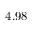<formula> <loc_0><loc_0><loc_500><loc_500>4 . 9 8</formula> 